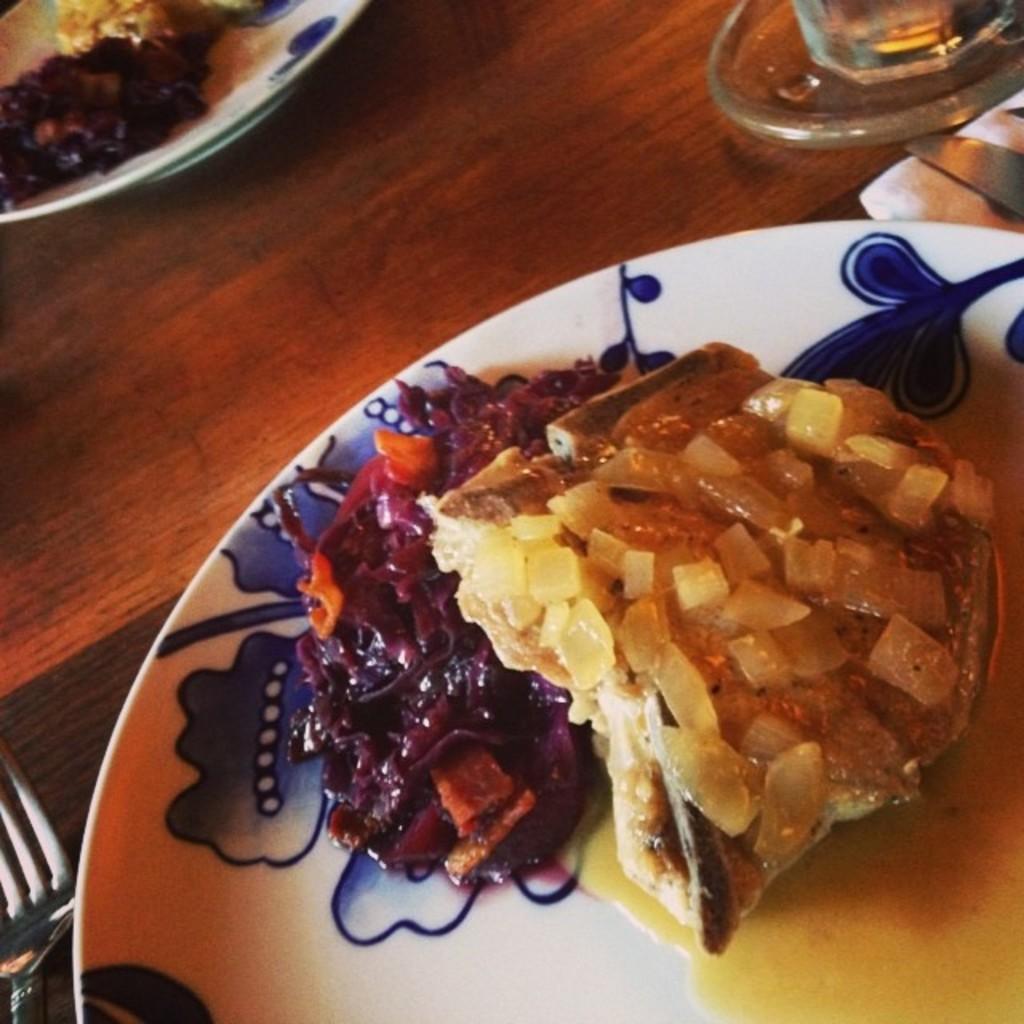Describe this image in one or two sentences. In this picture we can see there are plates, fork, knife, glass and a cloth on a wooden object. On the plate there are some food items. 